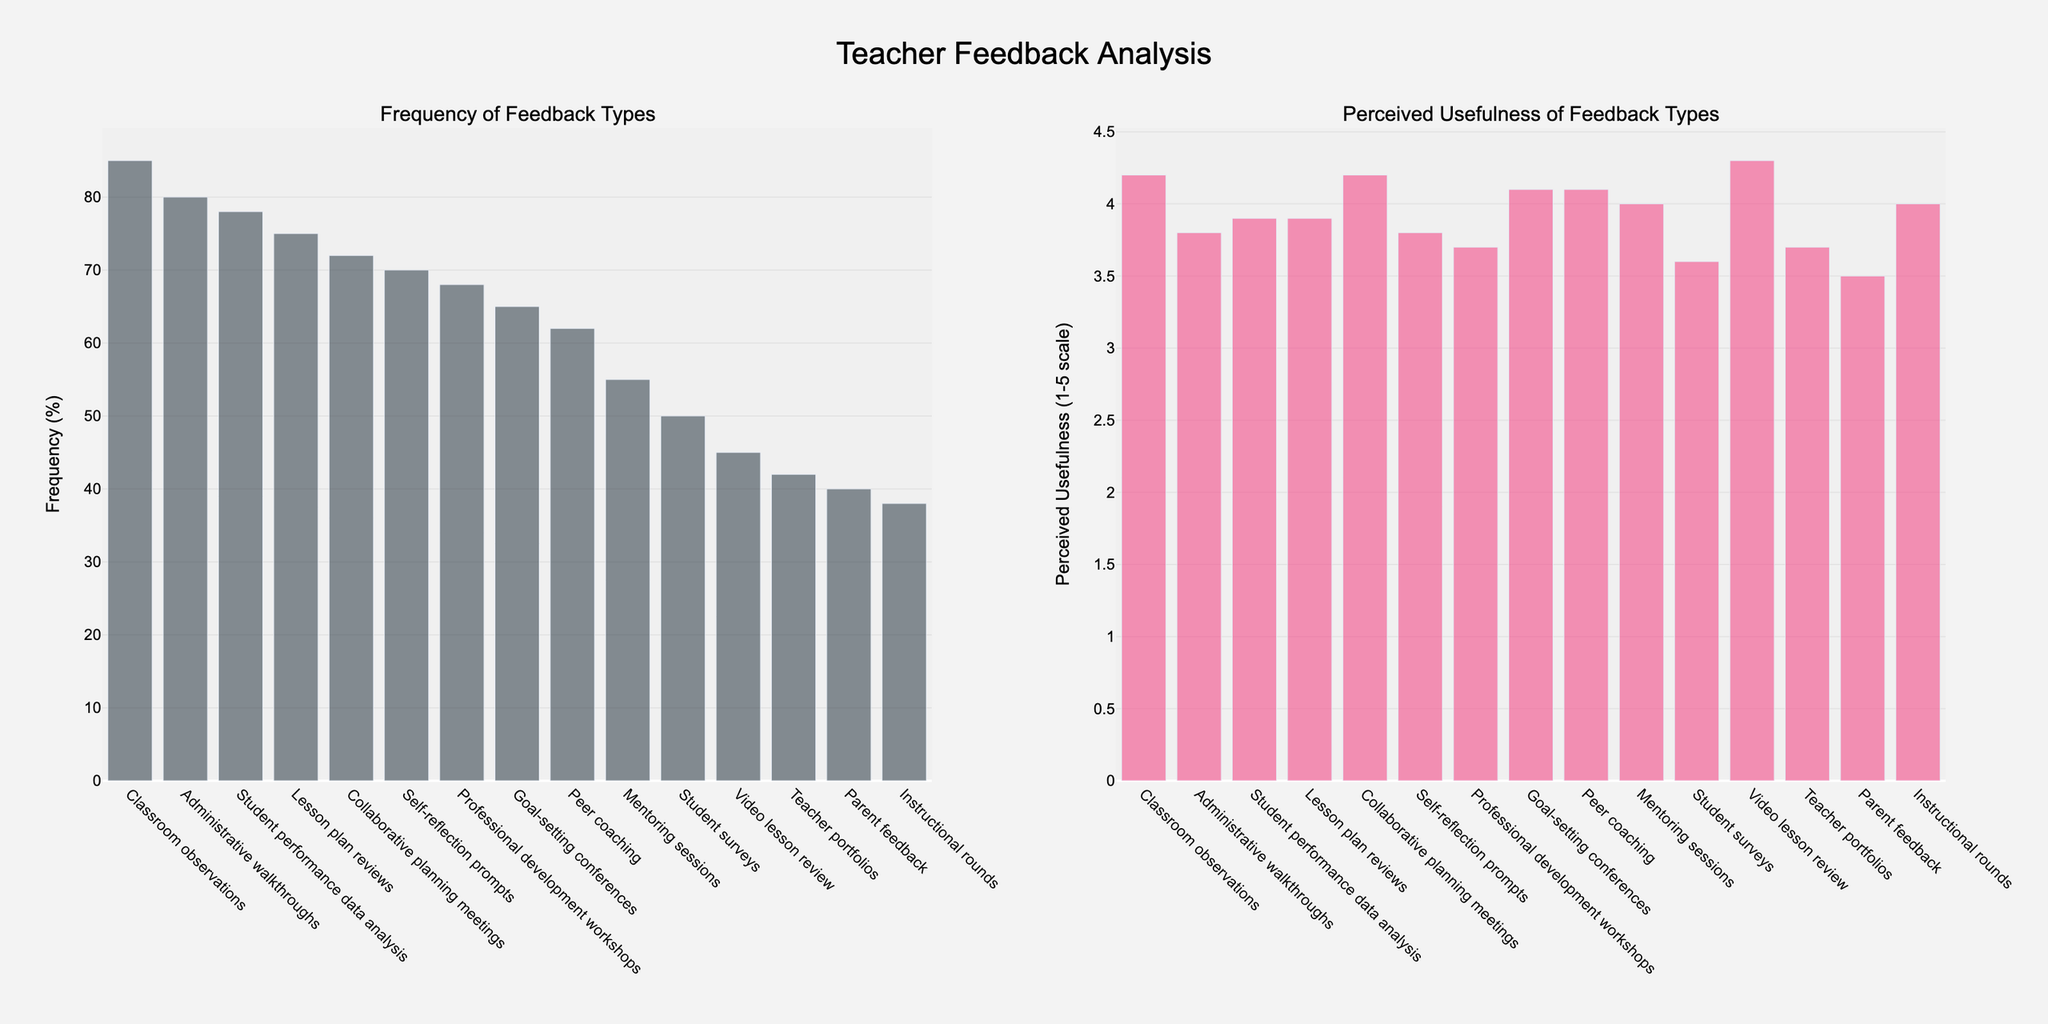How many types of feedback have a perceived usefulness greater than 4.0? Identify the feedback types with a perceived usefulness greater than 4.0 from the chart. Count these types. The feedback types with a perceived usefulness greater than 4.0 are Classroom observations, Peer coaching, Video lesson review, Collaborative planning meetings, and Goal-setting conferences, which total to 5.
Answer: 5 Which type of feedback has both high frequency (> 50%) and high perceived usefulness (> 4.0)? Locate feedback types with frequencies higher than 50% and perceived usefulness higher than 4.0. Classroom observations, Peer coaching, Collaborative planning meetings, and Goal-setting conferences all qualify.
Answer: Classroom observations, Peer coaching, Collaborative planning meetings, Goal-setting conferences What's the difference in perceived usefulness between the least used type of feedback and the most frequently used type? Identify the most and least used types of feedback: Classroom observations (most frequently used) with 85%, and Instructional rounds (least used) with 38%. Their perceived usefulness is 4.2 for Classroom observations and 4.0 for Instructional rounds. The difference is 4.2 - 4.0 = 0.2.
Answer: 0.2 Which type of feedback has the highest perceived usefulness and what is its frequency? Identify the bar with the highest perceived usefulness value and read its corresponding frequency from the chart. Video lesson review has the highest perceived usefulness of 4.3 with a frequency of 45%.
Answer: Video lesson review, 45% Among the five least frequent feedback types, which one has the highest perceived usefulness? Identify the five least frequent feedback types: Instructional rounds, Parent feedback, Teacher portfolios, Video lesson review, and Student surveys. Compare their perceived usefulness values and pick the highest one. Video lesson review has the highest perceived usefulness with a value of 4.3.
Answer: Video lesson review What is the average perceived usefulness of feedback types with frequency less than 60%? Identify feedback types with frequencies less than 60%: Peer coaching, Video lesson review, Parent feedback, Mentoring sessions, Student surveys, Instructional rounds, Teacher portfolios. Calculate their average usefulness: (4.1 + 4.3 + 3.5 + 4.0 + 3.6 + 4.0 + 3.7) / 7 = 3.89.
Answer: 3.89 Which type of feedback has the smallest gap between its frequency and perceived usefulness? Calculate the absolute difference between frequency and perceived usefulness for each type of feedback. Identify the type with the smallest difference. Peer coaching has a frequency of 62% and perceived usefulness of 4.1 (41%). The difference is 62 - 41 = 21, which is the smallest.
Answer: Peer coaching If we combine the frequencies of Classroom observations and Administrative walkthroughs, what percentage do they form of the combined total frequency? Calculate the combined frequency of Classroom observations and Administrative walkthroughs: 85% + 80% = 165%. Calculate the combined total frequency of all feedback types: 85 + 78 + 62 + 70 + 45 + 40 + 68 + 55 + 72 + 50 + 80 + 65 + 75 + 38 + 42 = 925%. The percentage is (165 / 925) * 100 approximately equals 17.84%.
Answer: 17.84% 